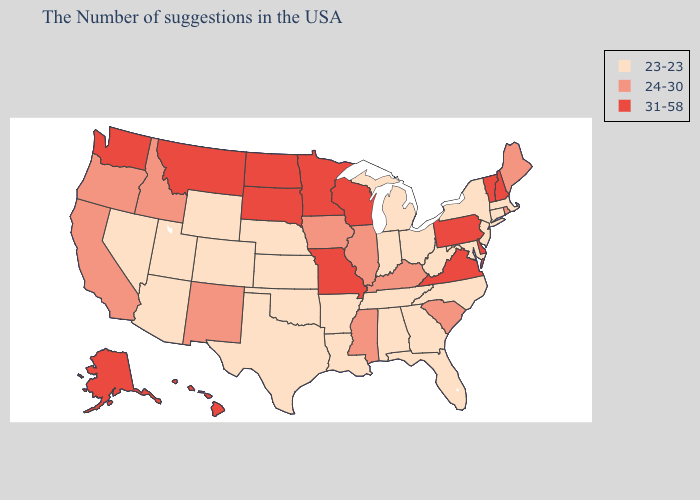What is the lowest value in states that border New York?
Keep it brief. 23-23. Does Mississippi have the lowest value in the South?
Write a very short answer. No. Name the states that have a value in the range 31-58?
Answer briefly. New Hampshire, Vermont, Delaware, Pennsylvania, Virginia, Wisconsin, Missouri, Minnesota, South Dakota, North Dakota, Montana, Washington, Alaska, Hawaii. Name the states that have a value in the range 24-30?
Give a very brief answer. Maine, Rhode Island, South Carolina, Kentucky, Illinois, Mississippi, Iowa, New Mexico, Idaho, California, Oregon. Which states have the lowest value in the USA?
Write a very short answer. Massachusetts, Connecticut, New York, New Jersey, Maryland, North Carolina, West Virginia, Ohio, Florida, Georgia, Michigan, Indiana, Alabama, Tennessee, Louisiana, Arkansas, Kansas, Nebraska, Oklahoma, Texas, Wyoming, Colorado, Utah, Arizona, Nevada. What is the value of Connecticut?
Keep it brief. 23-23. Name the states that have a value in the range 23-23?
Answer briefly. Massachusetts, Connecticut, New York, New Jersey, Maryland, North Carolina, West Virginia, Ohio, Florida, Georgia, Michigan, Indiana, Alabama, Tennessee, Louisiana, Arkansas, Kansas, Nebraska, Oklahoma, Texas, Wyoming, Colorado, Utah, Arizona, Nevada. Among the states that border California , does Oregon have the lowest value?
Short answer required. No. What is the value of South Carolina?
Keep it brief. 24-30. Name the states that have a value in the range 23-23?
Short answer required. Massachusetts, Connecticut, New York, New Jersey, Maryland, North Carolina, West Virginia, Ohio, Florida, Georgia, Michigan, Indiana, Alabama, Tennessee, Louisiana, Arkansas, Kansas, Nebraska, Oklahoma, Texas, Wyoming, Colorado, Utah, Arizona, Nevada. Among the states that border Wyoming , does Utah have the lowest value?
Be succinct. Yes. Among the states that border Ohio , which have the lowest value?
Short answer required. West Virginia, Michigan, Indiana. Does the map have missing data?
Concise answer only. No. Does Tennessee have a lower value than Utah?
Short answer required. No. What is the value of Pennsylvania?
Answer briefly. 31-58. 